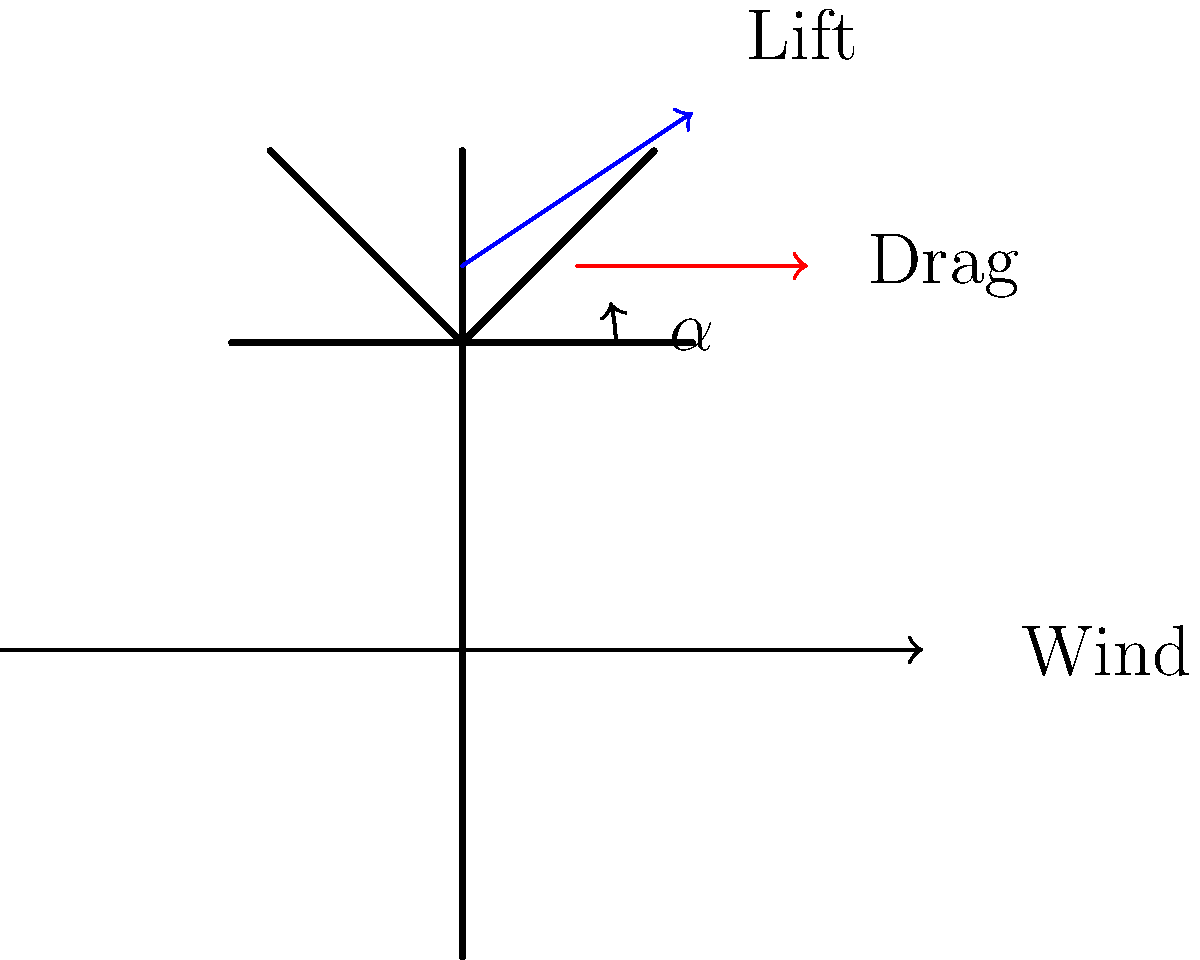As a lodge owner considering small-scale wind turbines for energy generation, you're studying the aerodynamics of turbine blades. The diagram shows a cross-section of a turbine blade. What is the primary factor that determines the optimal angle of attack ($\alpha$) for maximum lift-to-drag ratio, and how does this impact the efficiency of your potential wind turbine installation? To understand the optimal angle of attack for wind turbine blades, let's break down the key factors:

1. Angle of Attack ($\alpha$): This is the angle between the chord line of the airfoil (turbine blade cross-section) and the relative wind direction.

2. Lift and Drag Forces:
   - Lift force is perpendicular to the wind direction and is the main force driving the turbine rotation.
   - Drag force is parallel to the wind direction and opposes the motion.

3. Lift-to-Drag Ratio: The efficiency of the blade is determined by maximizing the lift-to-drag ratio.

4. Airfoil Shape: The primary factor determining the optimal angle of attack is the specific airfoil shape used for the turbine blade.

5. Reynolds Number: This dimensionless quantity, defined as $Re = \frac{\rho v L}{\mu}$ (where $\rho$ is air density, $v$ is wind speed, $L$ is characteristic length, and $\mu$ is air viscosity), also influences the optimal angle of attack.

6. Optimal Angle: For most airfoils, the optimal angle of attack for maximum lift-to-drag ratio is typically between 2° and 10°.

7. Efficiency Impact: Operating at the optimal angle of attack ensures:
   - Maximum power extraction from the wind
   - Reduced mechanical stress on the turbine components
   - Longer lifespan of the turbine
   - Higher overall energy production efficiency

8. Pitch Control: Modern wind turbines often use pitch control systems to adjust the blade angle and maintain optimal performance across varying wind conditions.

For your lodge's small-scale installation, choosing turbines with appropriate airfoil designs and, if possible, pitch control systems will help maximize energy generation efficiency.
Answer: Airfoil shape determines optimal angle of attack, maximizing lift-to-drag ratio and turbine efficiency. 